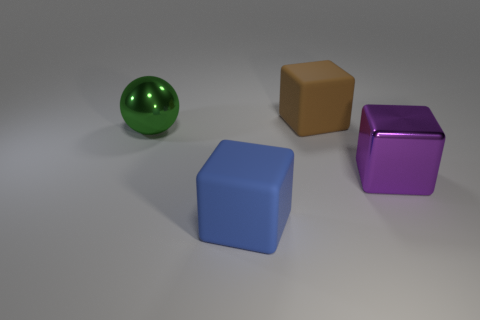Add 3 big brown matte cubes. How many objects exist? 7 Subtract all spheres. How many objects are left? 3 Subtract 1 green spheres. How many objects are left? 3 Subtract all small yellow metallic spheres. Subtract all big brown matte cubes. How many objects are left? 3 Add 1 shiny spheres. How many shiny spheres are left? 2 Add 1 purple metallic blocks. How many purple metallic blocks exist? 2 